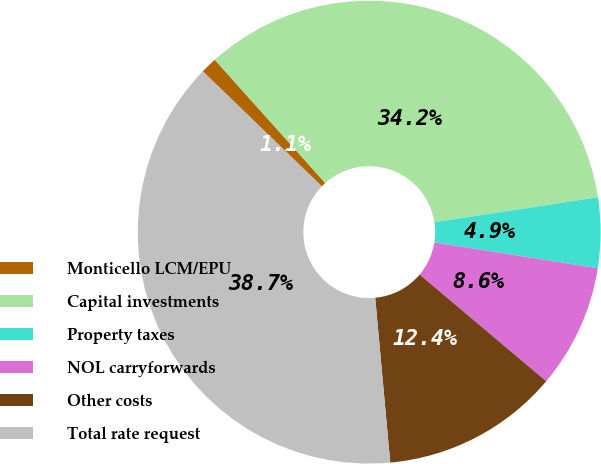Convert chart. <chart><loc_0><loc_0><loc_500><loc_500><pie_chart><fcel>Monticello LCM/EPU<fcel>Capital investments<fcel>Property taxes<fcel>NOL carryforwards<fcel>Other costs<fcel>Total rate request<nl><fcel>1.15%<fcel>34.22%<fcel>4.9%<fcel>8.65%<fcel>12.41%<fcel>38.67%<nl></chart> 